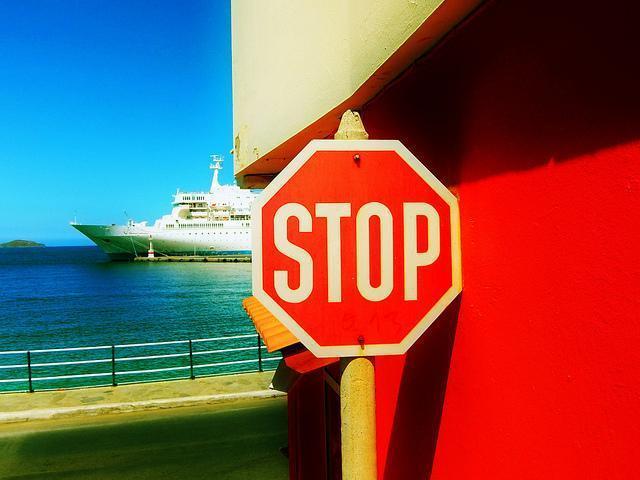How many stop signs is there?
Give a very brief answer. 1. How many stop signs are visible?
Give a very brief answer. 1. 